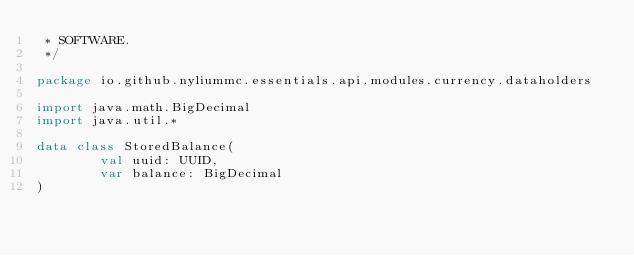<code> <loc_0><loc_0><loc_500><loc_500><_Kotlin_> * SOFTWARE.
 */

package io.github.nyliummc.essentials.api.modules.currency.dataholders

import java.math.BigDecimal
import java.util.*

data class StoredBalance(
        val uuid: UUID,
        var balance: BigDecimal
)</code> 